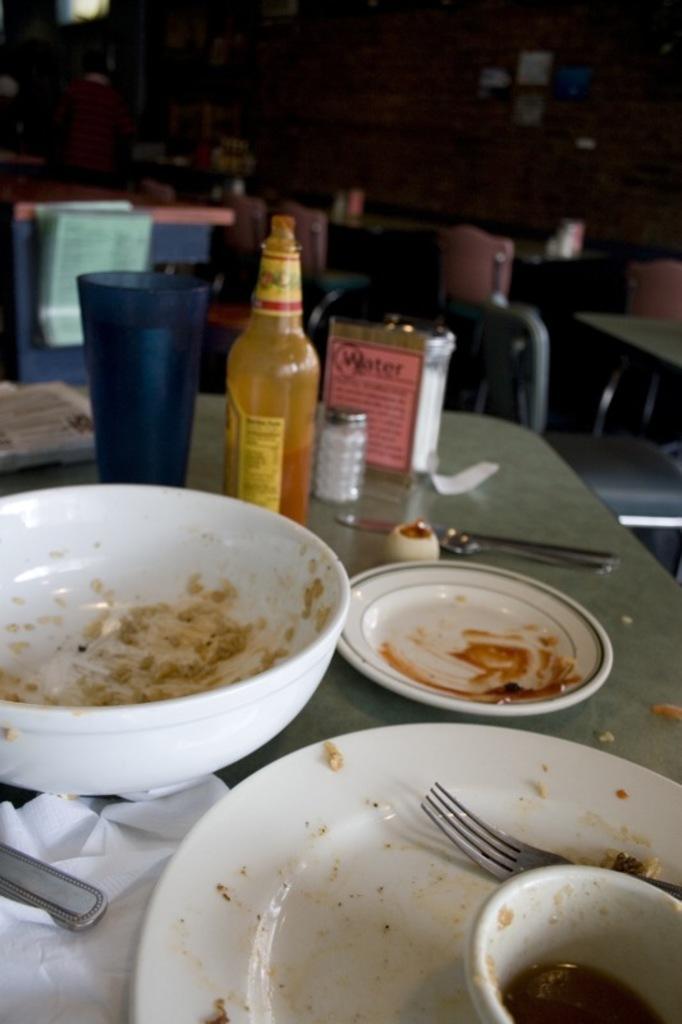Can you describe this image briefly? In this image there is a table having a bowl, plate, fork, bottle , glass on it. At right side there is a chair before which there is a table. At the left side there are few persons. 